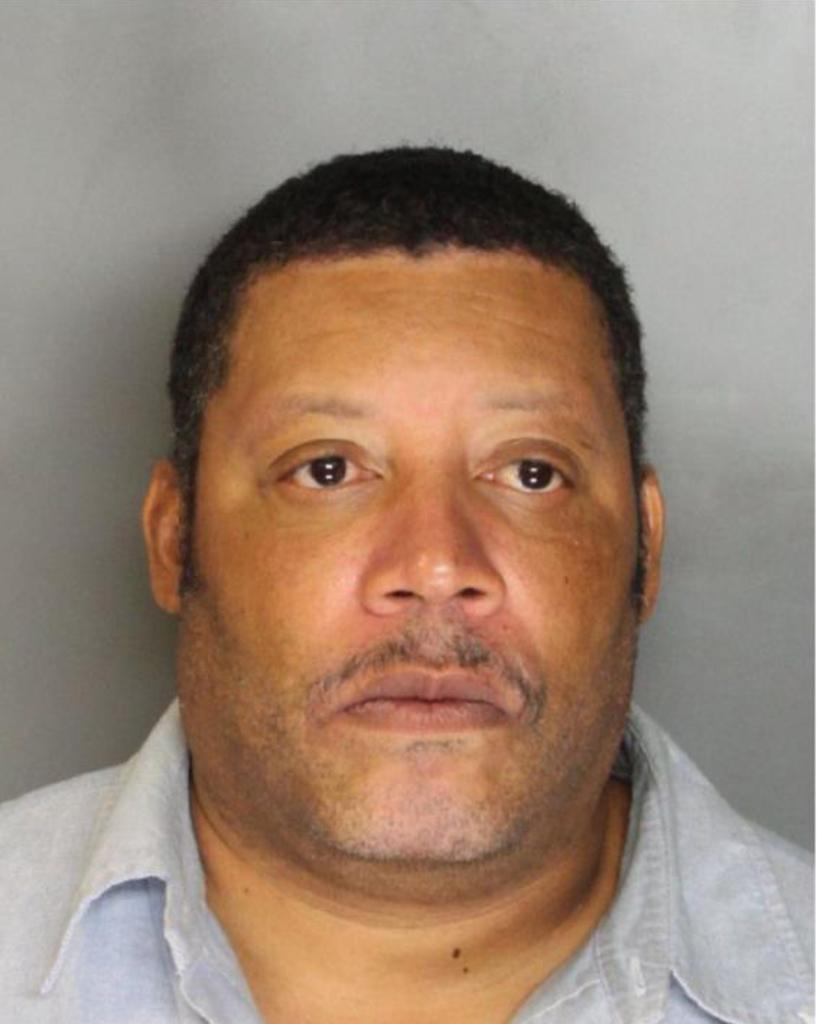Who or what is in the image? There is a person in the image. Can you describe the person's position? The person is in front. What can be seen behind the person? There is a wall behind the person. How many cables are attached to the bridge in the image? There is: There is no bridge present in the image, so it's not possible to determine the number of cables attached to it. 